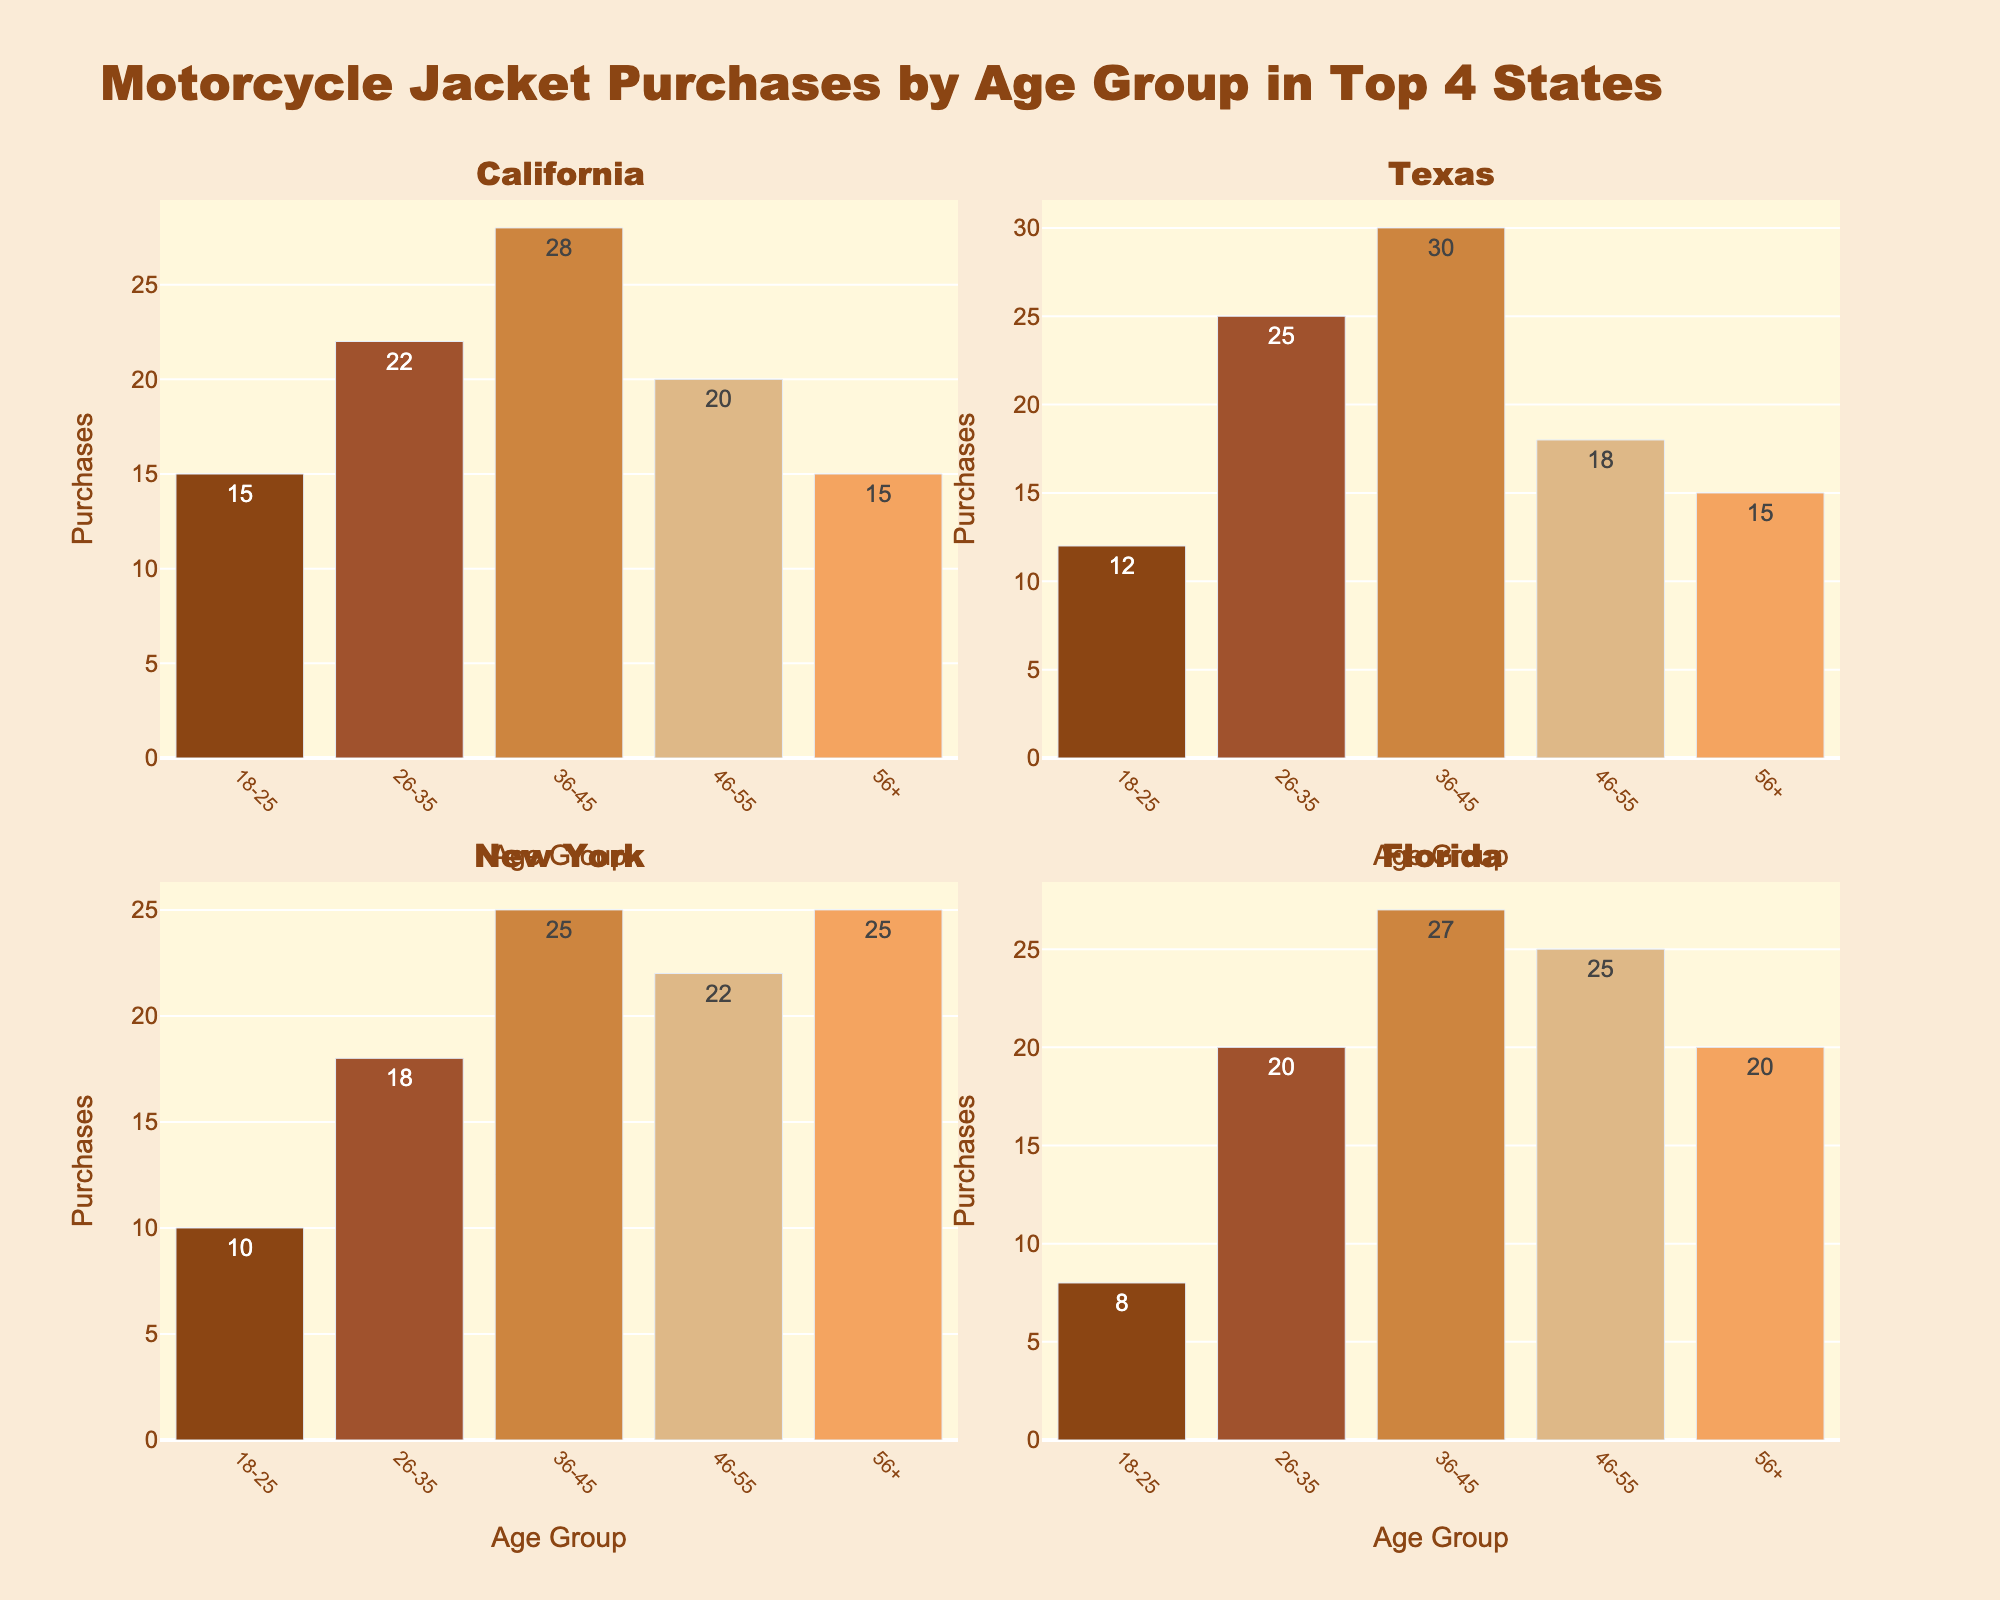What is the engagement rate for 'Driver Interviews' on Instagram? The engagement rate for 'Driver Interviews' on Instagram is directly shown on the bar corresponding to 'Driver Interviews' in the Instagram subplot.
Answer: 6.5% Which content type has the highest engagement rate on TikTok? The highest bar in the TikTok subplot represents 'Race Highlights', indicating it has the highest engagement rate on TikTok.
Answer: Race Highlights Compare the engagement rates for 'Technical Breakdowns' across all platforms: which platform has the highest engagement rate for this content type? The bar representing 'Technical Breakdowns' is highest in the YouTube subplot when compared to the Instagram, TikTok, and Twitter subplots.
Answer: YouTube How does the engagement rate of 'Behind-the-Scenes' content on YouTube compare to its engagement rate on TikTok? On the YouTube subplot, the bar for 'Behind-the-Scenes' indicates an engagement rate of 6.3, while on the TikTok subplot, the corresponding engagement rate is 11.5.
Answer: TikTok has a higher engagement rate What is the average engagement rate of 'Race Highlights' across all platforms? The engagement rates for 'Race Highlights' are: Instagram (8.2), TikTok (12.3), YouTube (6.9), and Twitter (4.7). Adding these rates gives a total of 32.1. Dividing by 4 (the number of platforms) gives the average engagement rate.
Answer: 8.025% Which platform has the lowest engagement rate overall, and which content type is it for? The lowest bar in all subplots is 'Technical Breakdowns' on Twitter, indicating the lowest overall engagement rate.
Answer: Twitter for 'Technical Breakdowns' Which content type shows the biggest difference in engagement rates between Instagram and TikTok? Calculate the differences: Race Highlights (4.1), Driver Interviews (3.2), Behind-the-Scenes (3.7), Technical Breakdowns (2.1). 'Race Highlights' has the biggest difference.
Answer: Race Highlights List the content types on Twitter ordered by engagement rate from highest to lowest. From the Twitter subplot: Race Highlights (4.7), Behind-the-Scenes (4.2), Driver Interviews (3.9), Technical Breakdowns (3.5).
Answer: Race Highlights, Behind-the-Scenes, Driver Interviews, Technical Breakdowns What is the combined engagement rate of all content types on Instagram? Add the engagement rates for all content types on Instagram: 8.2 (Race Highlights) + 6.5 (Driver Interviews) + 7.8 (Behind-the-Scenes) + 5.1 (Technical Breakdowns) = 27.6.
Answer: 27.6% 